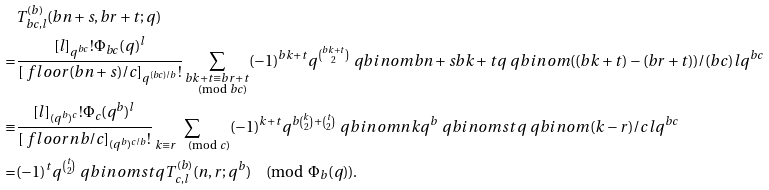Convert formula to latex. <formula><loc_0><loc_0><loc_500><loc_500>& T _ { b c , l } ^ { ( b ) } ( b n + s , b r + t ; q ) \\ = & \frac { [ l ] _ { q ^ { b c } } ! \Phi _ { b c } ( q ) ^ { l } } { [ \ f l o o r { ( b n + s ) / c } ] _ { q ^ { ( b c ) / b } } ! } \sum _ { \substack { b k + t \equiv b r + t \\ \pmod { b c } } } ( - 1 ) ^ { b k + t } q ^ { \binom { b k + t } { 2 } } \ q b i n o m { b n + s } { b k + t } { q } \ q b i n o m { ( ( b k + t ) - ( b r + t ) ) / ( b c ) } { l } { q ^ { b c } } \\ \equiv & \frac { [ l ] _ { ( q ^ { b } ) ^ { c } } ! \Phi _ { c } ( q ^ { b } ) ^ { l } } { [ \ f l o o r { n b / c } ] _ { ( q ^ { b } ) ^ { c / b } } ! } \sum _ { k \equiv r \pmod { c } } ( - 1 ) ^ { k + t } q ^ { b \binom { k } { 2 } + \binom { t } { 2 } } \ q b i n o m { n } { k } { q ^ { b } } \ q b i n o m { s } { t } { q } \ q b i n o m { ( k - r ) / c } { l } { q ^ { b c } } \\ = & ( - 1 ) ^ { t } q ^ { \binom { t } { 2 } } \ q b i n o m { s } { t } { q } T _ { c , l } ^ { ( b ) } ( n , r ; q ^ { b } ) \pmod { \Phi _ { b } ( q ) } .</formula> 